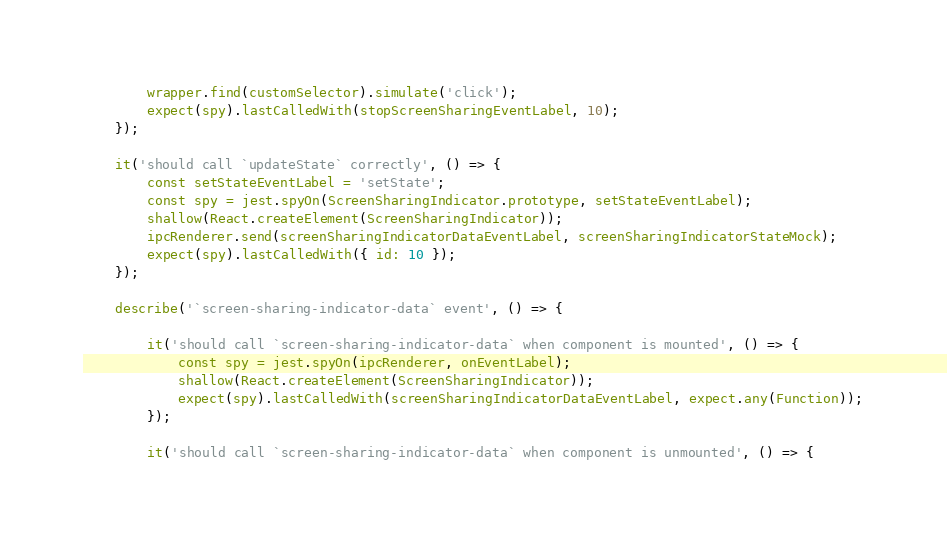<code> <loc_0><loc_0><loc_500><loc_500><_TypeScript_>        wrapper.find(customSelector).simulate('click');
        expect(spy).lastCalledWith(stopScreenSharingEventLabel, 10);
    });

    it('should call `updateState` correctly', () => {
        const setStateEventLabel = 'setState';
        const spy = jest.spyOn(ScreenSharingIndicator.prototype, setStateEventLabel);
        shallow(React.createElement(ScreenSharingIndicator));
        ipcRenderer.send(screenSharingIndicatorDataEventLabel, screenSharingIndicatorStateMock);
        expect(spy).lastCalledWith({ id: 10 });
    });

    describe('`screen-sharing-indicator-data` event', () => {

        it('should call `screen-sharing-indicator-data` when component is mounted', () => {
            const spy = jest.spyOn(ipcRenderer, onEventLabel);
            shallow(React.createElement(ScreenSharingIndicator));
            expect(spy).lastCalledWith(screenSharingIndicatorDataEventLabel, expect.any(Function));
        });

        it('should call `screen-sharing-indicator-data` when component is unmounted', () => {</code> 